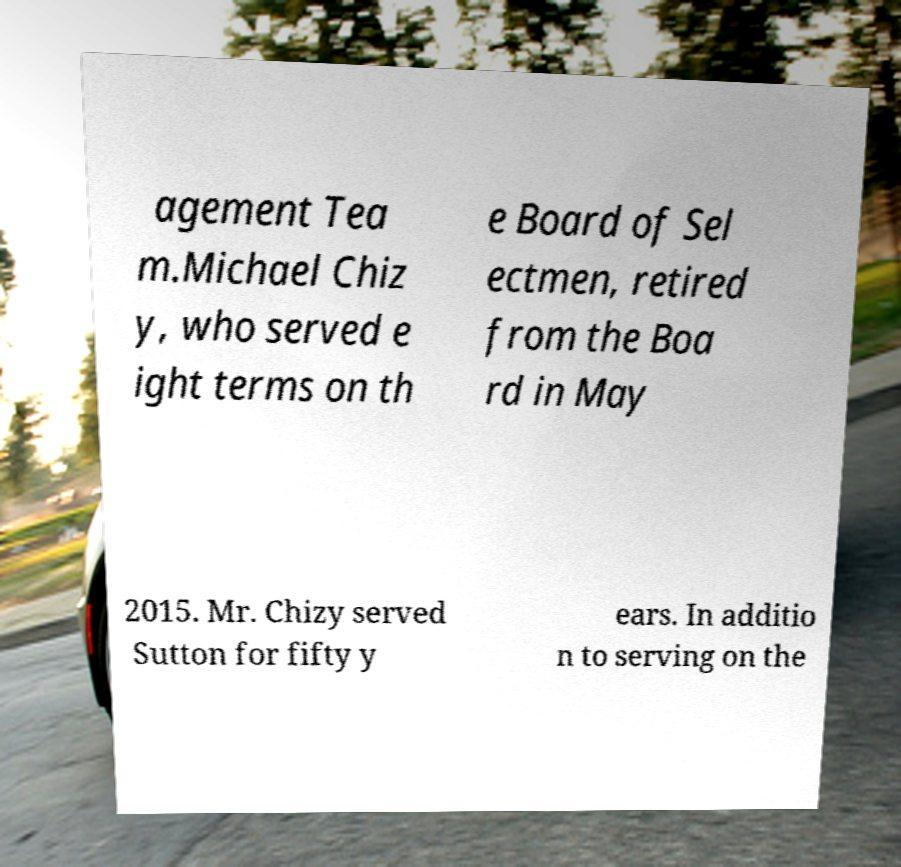Could you assist in decoding the text presented in this image and type it out clearly? agement Tea m.Michael Chiz y, who served e ight terms on th e Board of Sel ectmen, retired from the Boa rd in May 2015. Mr. Chizy served Sutton for fifty y ears. In additio n to serving on the 